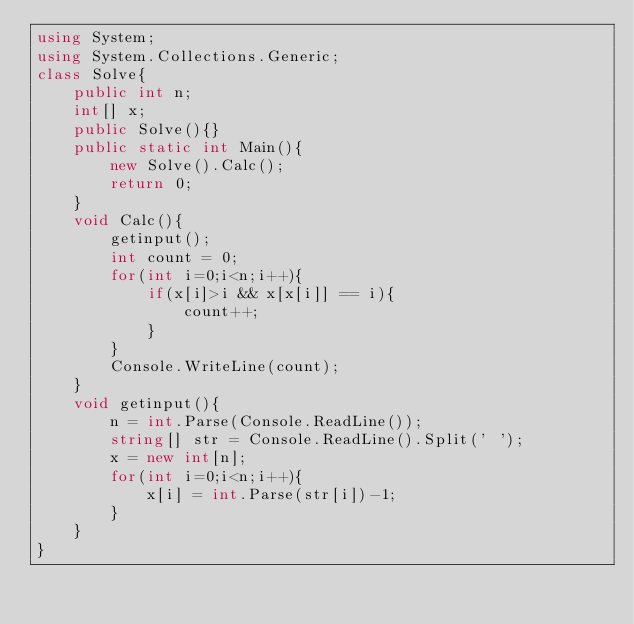Convert code to text. <code><loc_0><loc_0><loc_500><loc_500><_C#_>using System;
using System.Collections.Generic;
class Solve{
    public int n;
    int[] x;
    public Solve(){}
    public static int Main(){
        new Solve().Calc();
        return 0;
    }
    void Calc(){
        getinput();
        int count = 0;
        for(int i=0;i<n;i++){
            if(x[i]>i && x[x[i]] == i){
                count++;
            }
        }
        Console.WriteLine(count);
    }
    void getinput(){
        n = int.Parse(Console.ReadLine());
        string[] str = Console.ReadLine().Split(' ');
        x = new int[n];
        for(int i=0;i<n;i++){
            x[i] = int.Parse(str[i])-1;
        }
    }    
}</code> 